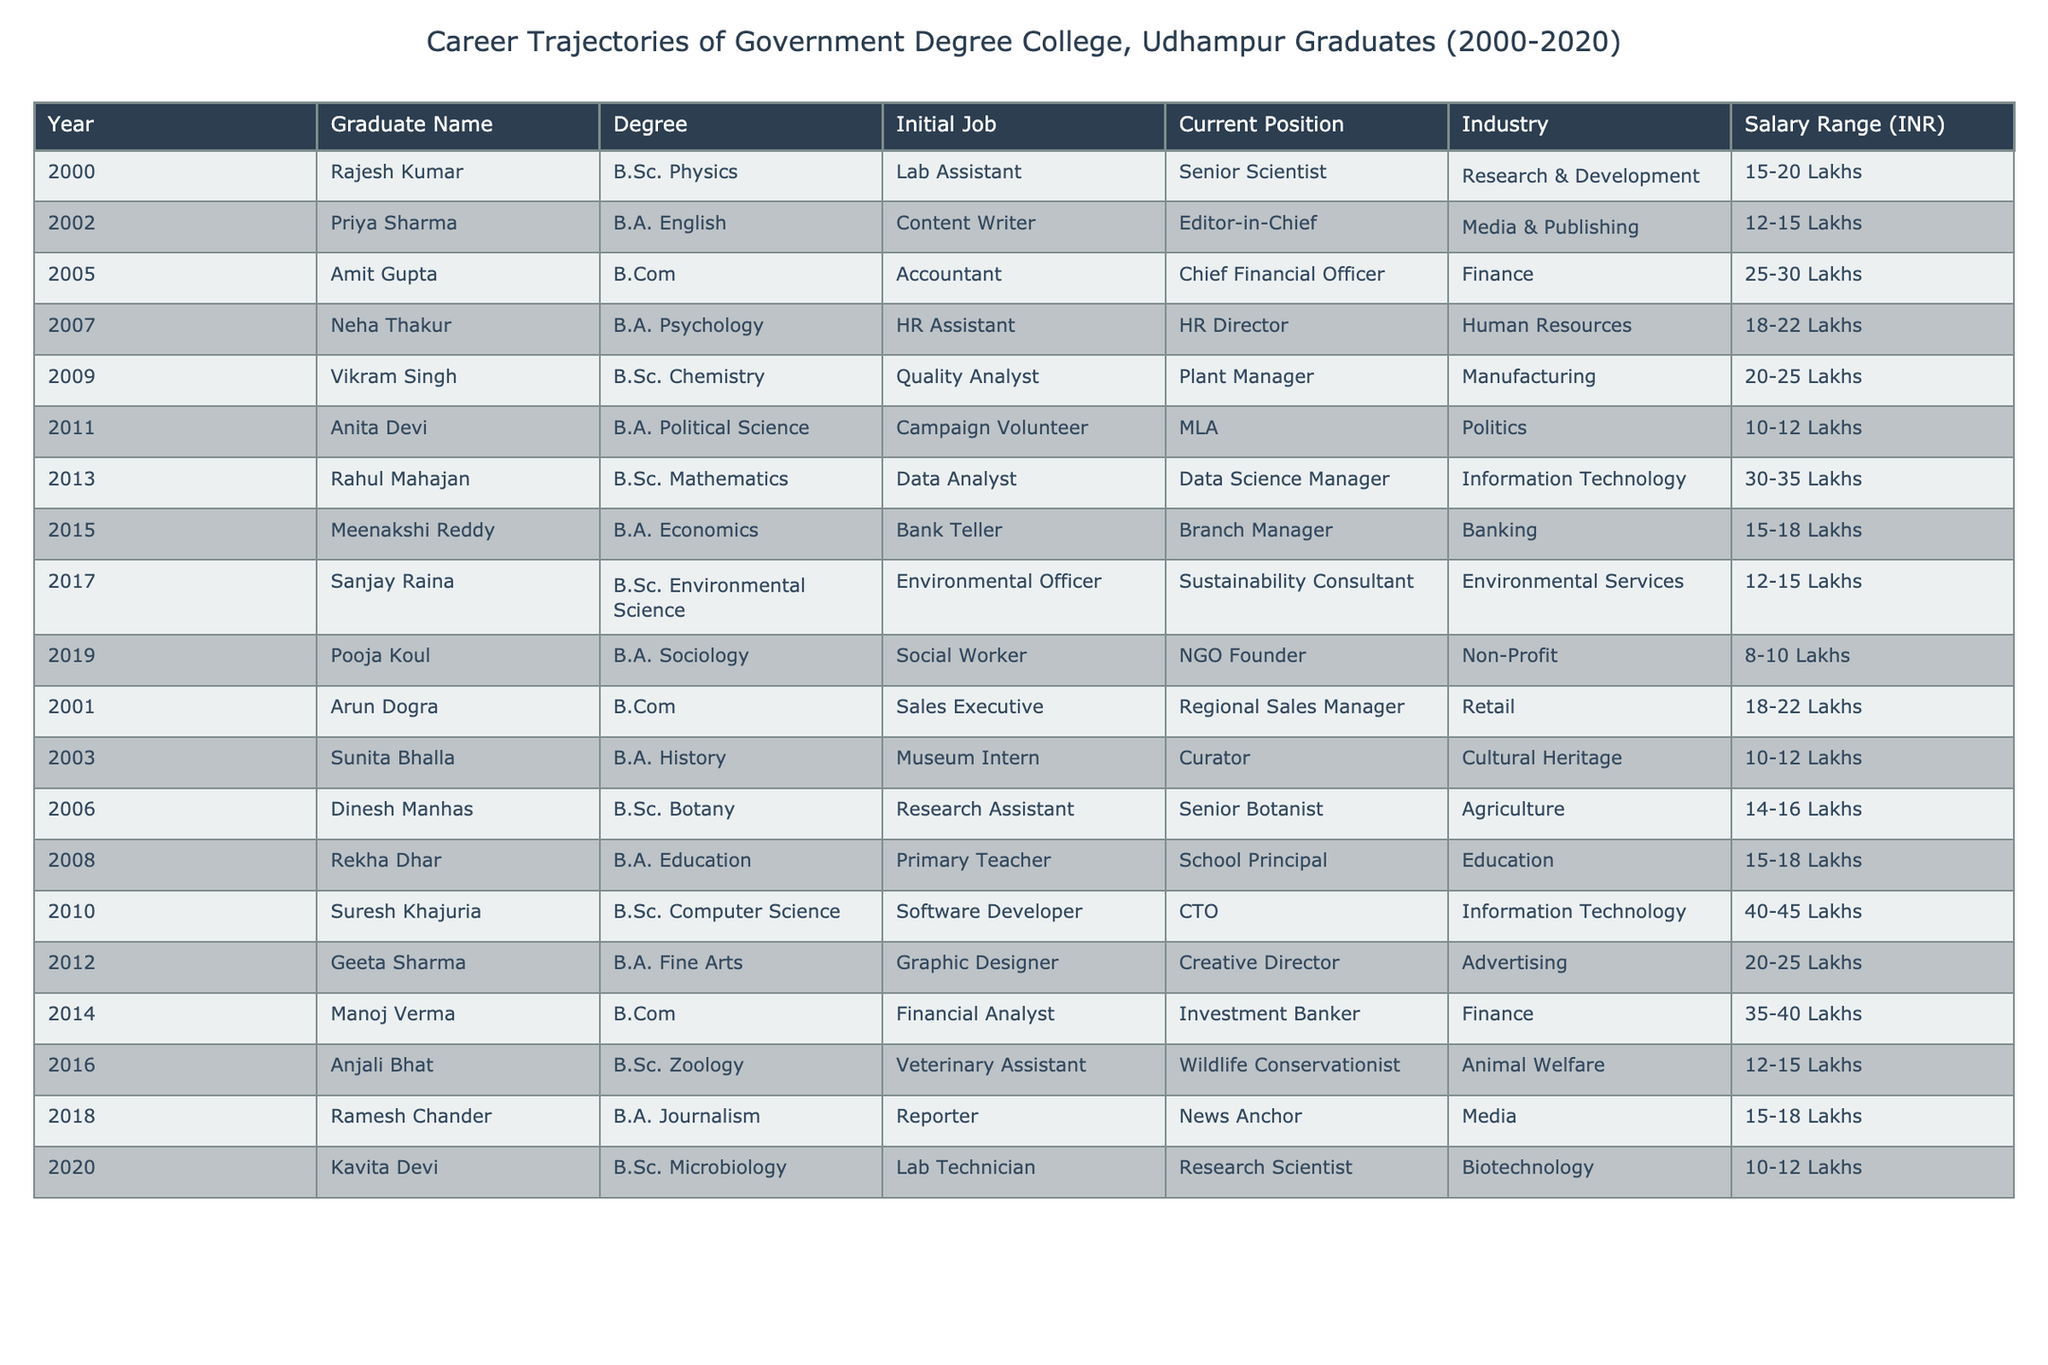What is the highest current position held by a graduate from the table? The graduate with the highest current position is Suresh Khajuria, who is the CTO.
Answer: CTO How many graduates have a current position in the finance industry? There are three graduates currently working in the finance industry: Amit Gupta (CFO), Manoj Verma (Investment Banker), and another from the table who works in the banking sector.
Answer: 3 Which graduate has the lowest salary range and what is it? Pooja Koul has the lowest salary range, which is 8-10 Lakhs.
Answer: 8-10 Lakhs What is the average salary range for graduates working in the Information Technology industry? The graduates in IT are Rahul Mahajan (30-35 Lakhs) and Suresh Khajuria (40-45 Lakhs). The average is calculated as follows: (32.5 + 42.5)/2 = 35 Lakhs.
Answer: 35 Lakhs Is there any graduate who works in the non-profit sector? Yes, Pooja Koul works as a Social Worker and is the founder of an NGO, which is part of the non-profit sector.
Answer: Yes What is the difference in the number of graduates between the B.A. and B.Sc. degrees? There are 10 B.A. graduates and 10 B.Sc. graduates in the table, which results in a difference of 0.
Answer: 0 Who had a career change from a Lab Assistant to a Senior Scientist, and in what year did they graduate? Rajesh Kumar graduated in 2000 and transitioned from being a Lab Assistant to a Senior Scientist.
Answer: Rajesh Kumar, 2000 What percentage of graduates currently hold senior or director-level positions? The graduates in senior or director-level positions are Rajesh Kumar, Amit Gupta, Neha Thakur, Suresh Khajuria, Manoj Verma, and Suresh Khajuria, totaling 6 out of 20 graduates, which is (6/20)*100 = 30%.
Answer: 30% How many graduates from the table have transitioned into a position related to media? There are two graduates related to media: Priya Sharma (Editor-in-Chief) and Ramesh Chander (News Anchor).
Answer: 2 What is the total salary range of all graduates listed from 2000 to 2020? The total salary ranges are: 15-20, 12-15, 25-30, 18-22, 20-25, 10-12, 30-35, 15-18, 12-15, 8-10, 18-22, 10-12, 14-16, 15-18, 40-45, 20-25, 35-40, 12-15, 15-18, 10-12. Summing the minimum and maximum values gives 305-355 Lakhs overall.
Answer: 305-355 Lakhs Was there any graduate from the table who started in education and reached a senior position in the same field? Yes, Rekha Dhar started as a Primary Teacher and is currently a School Principal, staying within the education sector.
Answer: Yes 